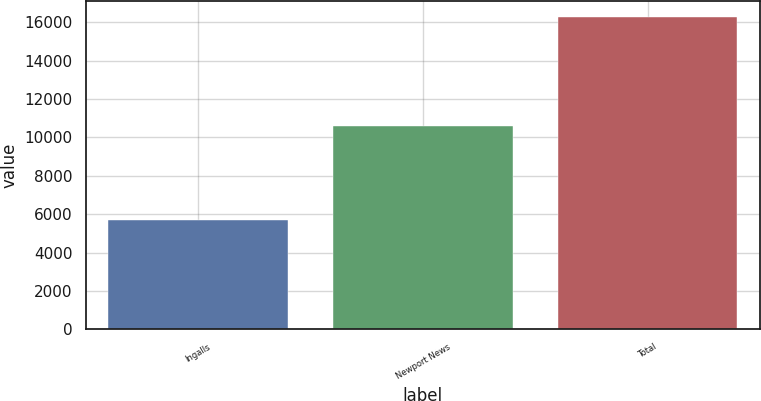<chart> <loc_0><loc_0><loc_500><loc_500><bar_chart><fcel>Ingalls<fcel>Newport News<fcel>Total<nl><fcel>5696<fcel>10572<fcel>16268<nl></chart> 